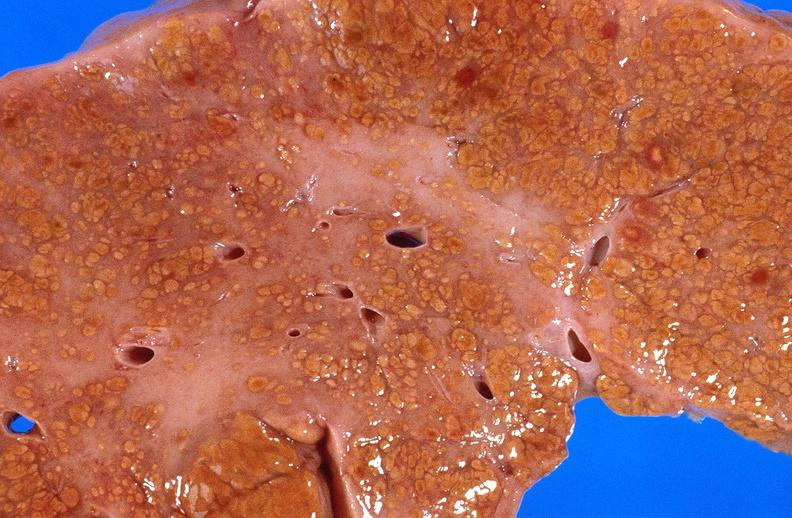s lesion present?
Answer the question using a single word or phrase. No 